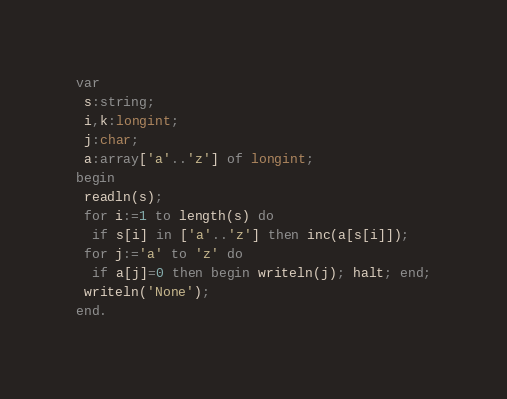Convert code to text. <code><loc_0><loc_0><loc_500><loc_500><_Pascal_>var
 s:string;
 i,k:longint;
 j:char;
 a:array['a'..'z'] of longint; 
begin
 readln(s);
 for i:=1 to length(s) do
  if s[i] in ['a'..'z'] then inc(a[s[i]]);
 for j:='a' to 'z' do
  if a[j]=0 then begin writeln(j); halt; end;
 writeln('None');
end.</code> 